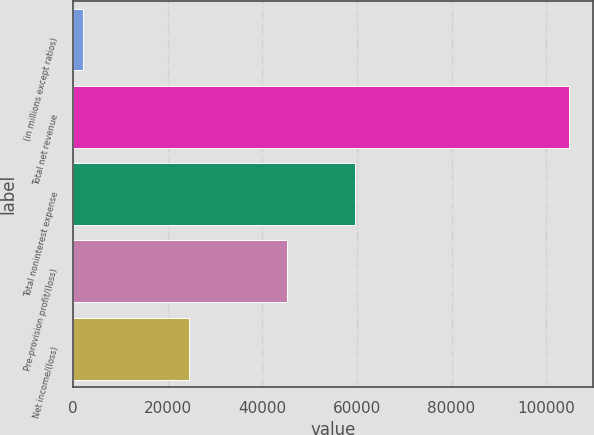Convert chart. <chart><loc_0><loc_0><loc_500><loc_500><bar_chart><fcel>(in millions except ratios)<fcel>Total net revenue<fcel>Total noninterest expense<fcel>Pre-provision profit/(loss)<fcel>Net income/(loss)<nl><fcel>2017<fcel>104722<fcel>59515<fcel>45207<fcel>24441<nl></chart> 